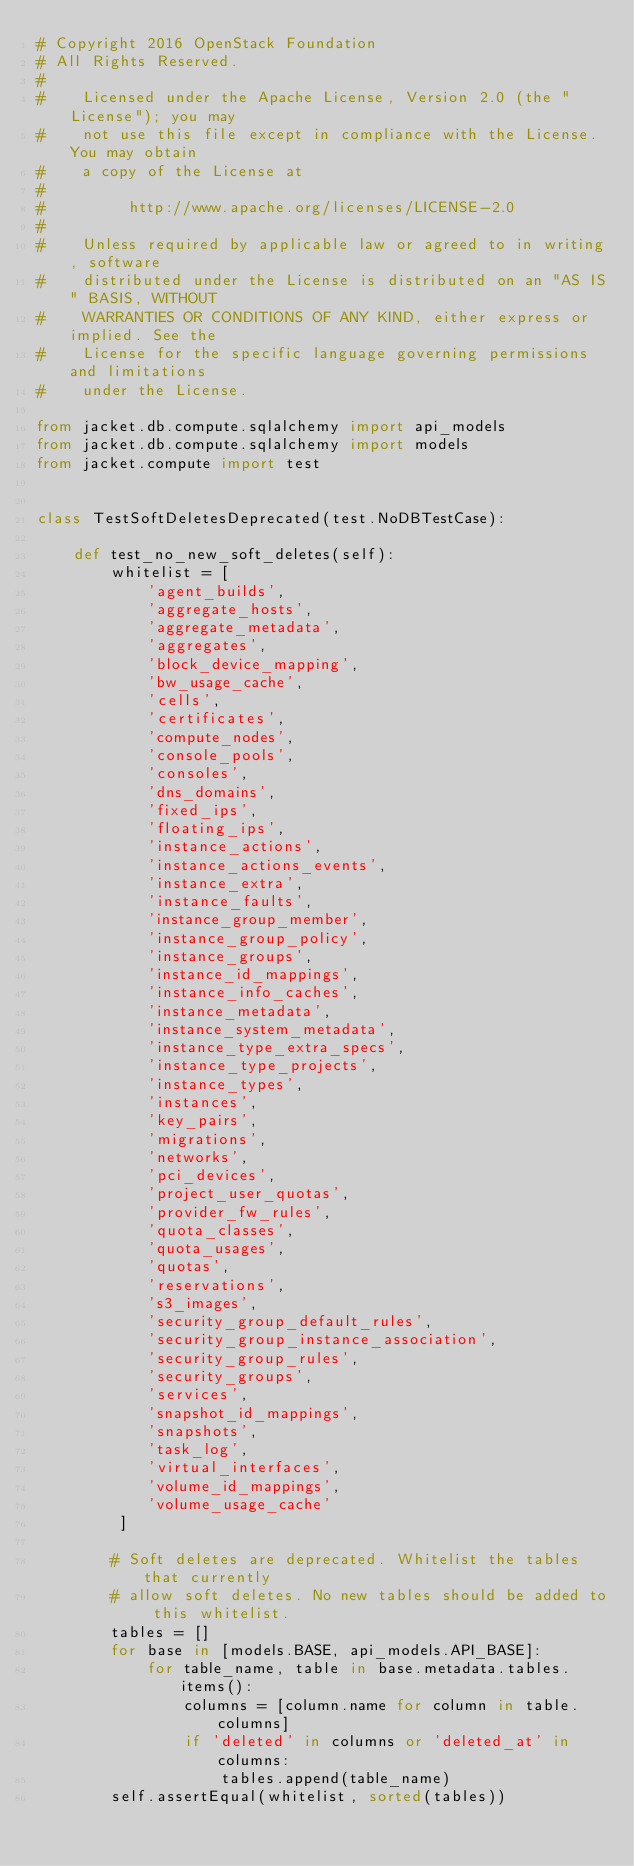<code> <loc_0><loc_0><loc_500><loc_500><_Python_># Copyright 2016 OpenStack Foundation
# All Rights Reserved.
#
#    Licensed under the Apache License, Version 2.0 (the "License"); you may
#    not use this file except in compliance with the License. You may obtain
#    a copy of the License at
#
#         http://www.apache.org/licenses/LICENSE-2.0
#
#    Unless required by applicable law or agreed to in writing, software
#    distributed under the License is distributed on an "AS IS" BASIS, WITHOUT
#    WARRANTIES OR CONDITIONS OF ANY KIND, either express or implied. See the
#    License for the specific language governing permissions and limitations
#    under the License.

from jacket.db.compute.sqlalchemy import api_models
from jacket.db.compute.sqlalchemy import models
from jacket.compute import test


class TestSoftDeletesDeprecated(test.NoDBTestCase):

    def test_no_new_soft_deletes(self):
        whitelist = [
            'agent_builds',
            'aggregate_hosts',
            'aggregate_metadata',
            'aggregates',
            'block_device_mapping',
            'bw_usage_cache',
            'cells',
            'certificates',
            'compute_nodes',
            'console_pools',
            'consoles',
            'dns_domains',
            'fixed_ips',
            'floating_ips',
            'instance_actions',
            'instance_actions_events',
            'instance_extra',
            'instance_faults',
            'instance_group_member',
            'instance_group_policy',
            'instance_groups',
            'instance_id_mappings',
            'instance_info_caches',
            'instance_metadata',
            'instance_system_metadata',
            'instance_type_extra_specs',
            'instance_type_projects',
            'instance_types',
            'instances',
            'key_pairs',
            'migrations',
            'networks',
            'pci_devices',
            'project_user_quotas',
            'provider_fw_rules',
            'quota_classes',
            'quota_usages',
            'quotas',
            'reservations',
            's3_images',
            'security_group_default_rules',
            'security_group_instance_association',
            'security_group_rules',
            'security_groups',
            'services',
            'snapshot_id_mappings',
            'snapshots',
            'task_log',
            'virtual_interfaces',
            'volume_id_mappings',
            'volume_usage_cache'
         ]

        # Soft deletes are deprecated. Whitelist the tables that currently
        # allow soft deletes. No new tables should be added to this whitelist.
        tables = []
        for base in [models.BASE, api_models.API_BASE]:
            for table_name, table in base.metadata.tables.items():
                columns = [column.name for column in table.columns]
                if 'deleted' in columns or 'deleted_at' in columns:
                    tables.append(table_name)
        self.assertEqual(whitelist, sorted(tables))
</code> 